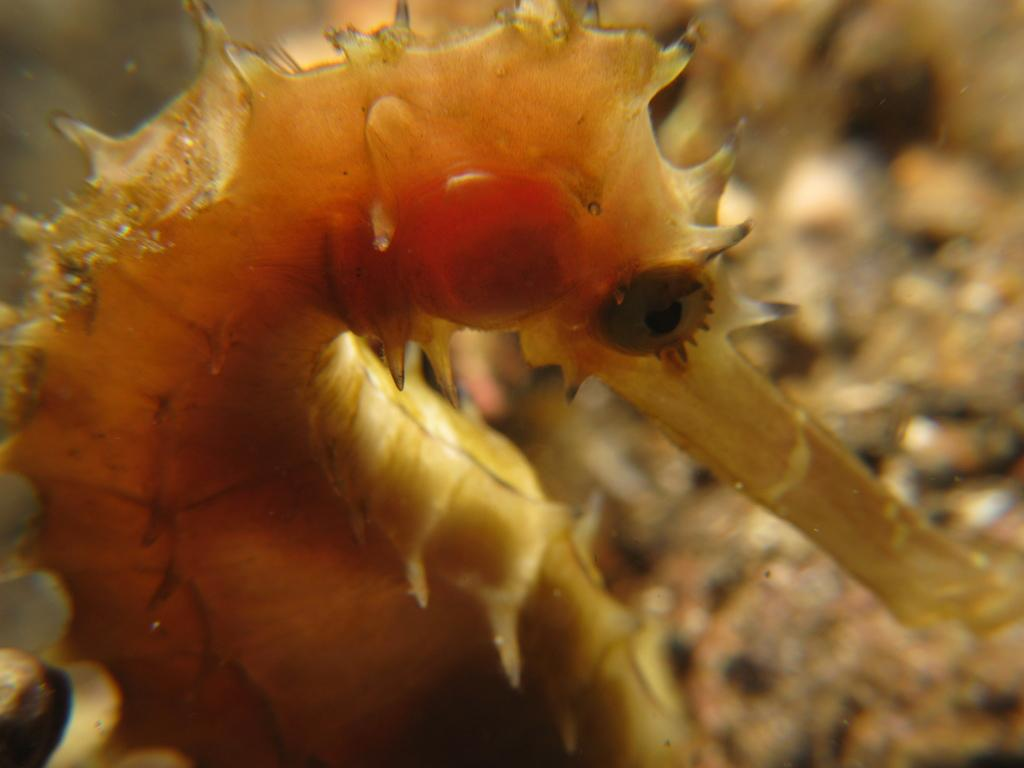What type of creature can be seen in the image? There is an insect in the image. How does the crowd affect the distribution of the insect in the image? There is no crowd present in the image, and therefore the distribution of the insect is not affected by a crowd. 